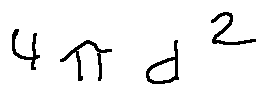<formula> <loc_0><loc_0><loc_500><loc_500>4 \pi d ^ { 2 }</formula> 